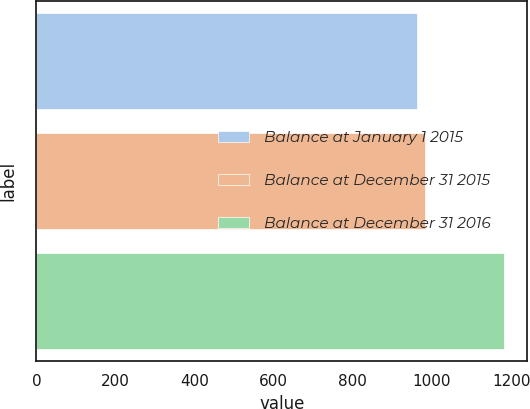<chart> <loc_0><loc_0><loc_500><loc_500><bar_chart><fcel>Balance at January 1 2015<fcel>Balance at December 31 2015<fcel>Balance at December 31 2016<nl><fcel>961<fcel>983.1<fcel>1182<nl></chart> 